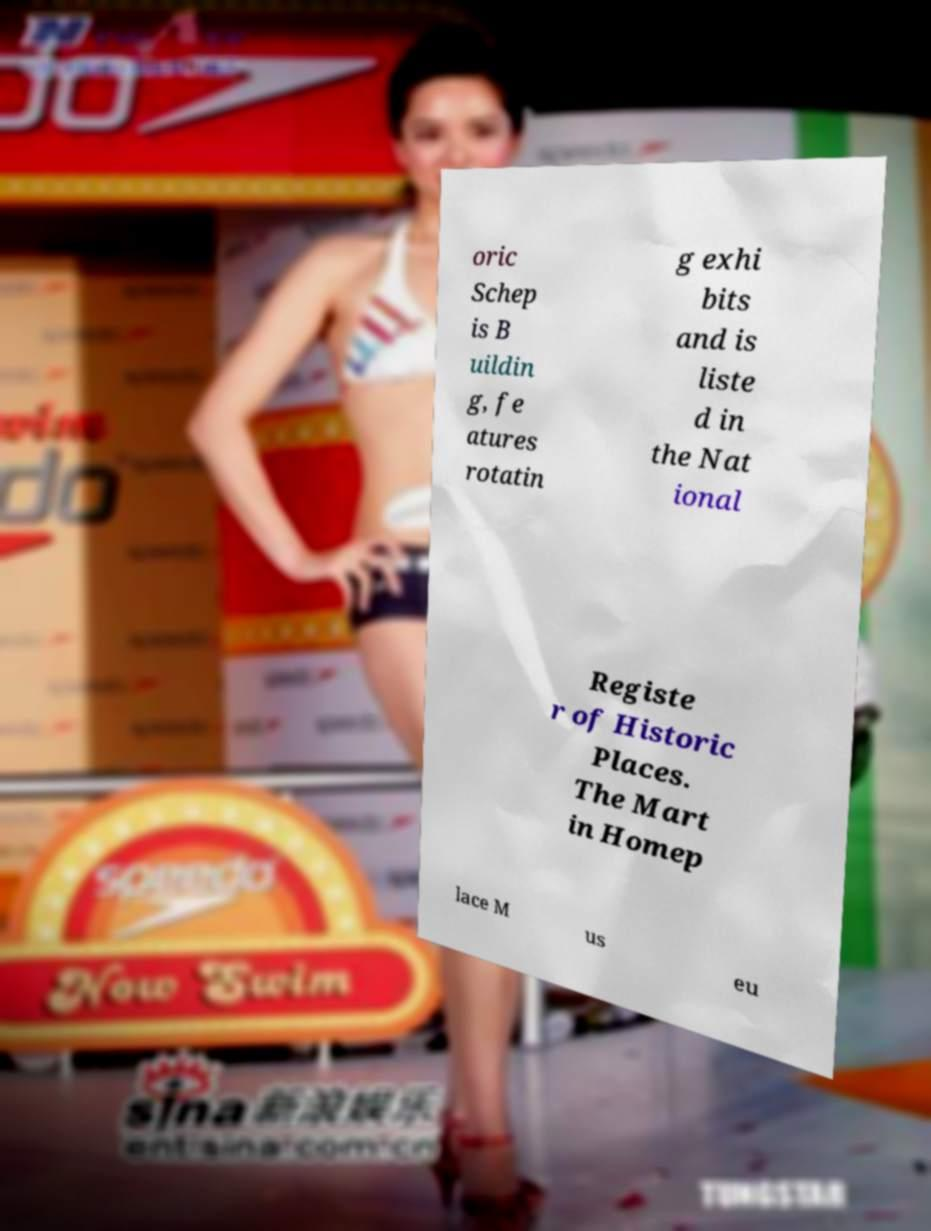Could you assist in decoding the text presented in this image and type it out clearly? oric Schep is B uildin g, fe atures rotatin g exhi bits and is liste d in the Nat ional Registe r of Historic Places. The Mart in Homep lace M us eu 